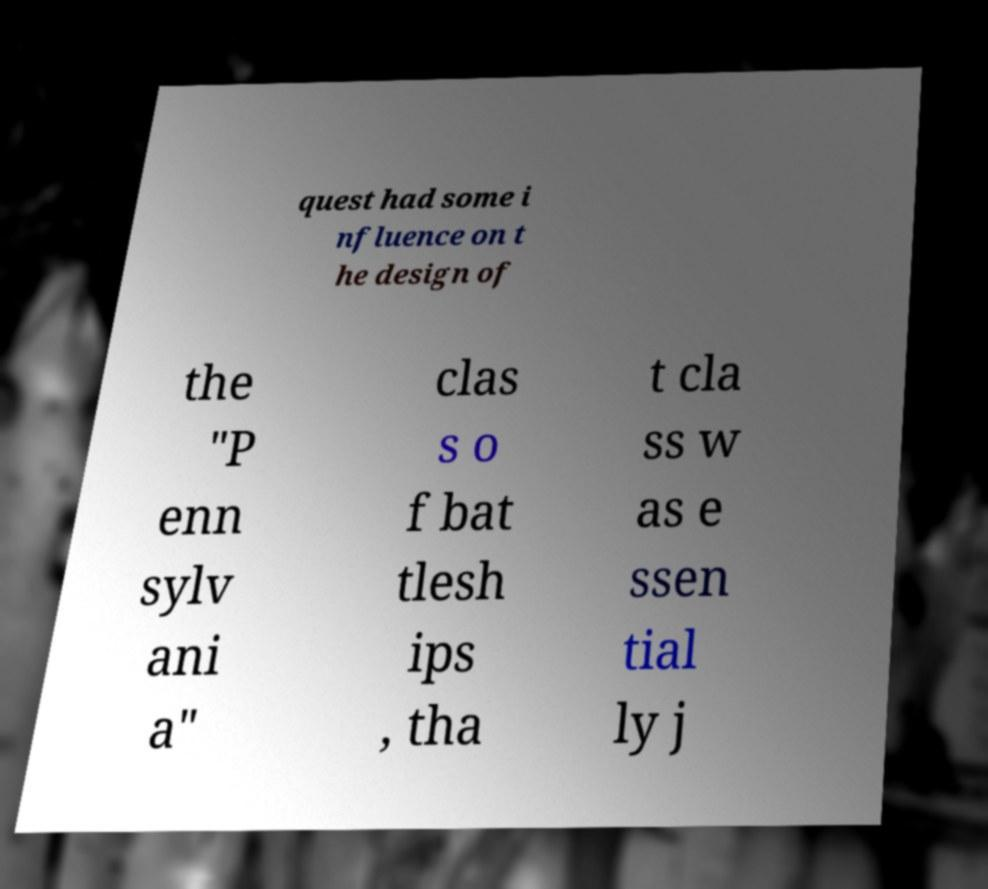Please read and relay the text visible in this image. What does it say? quest had some i nfluence on t he design of the "P enn sylv ani a" clas s o f bat tlesh ips , tha t cla ss w as e ssen tial ly j 